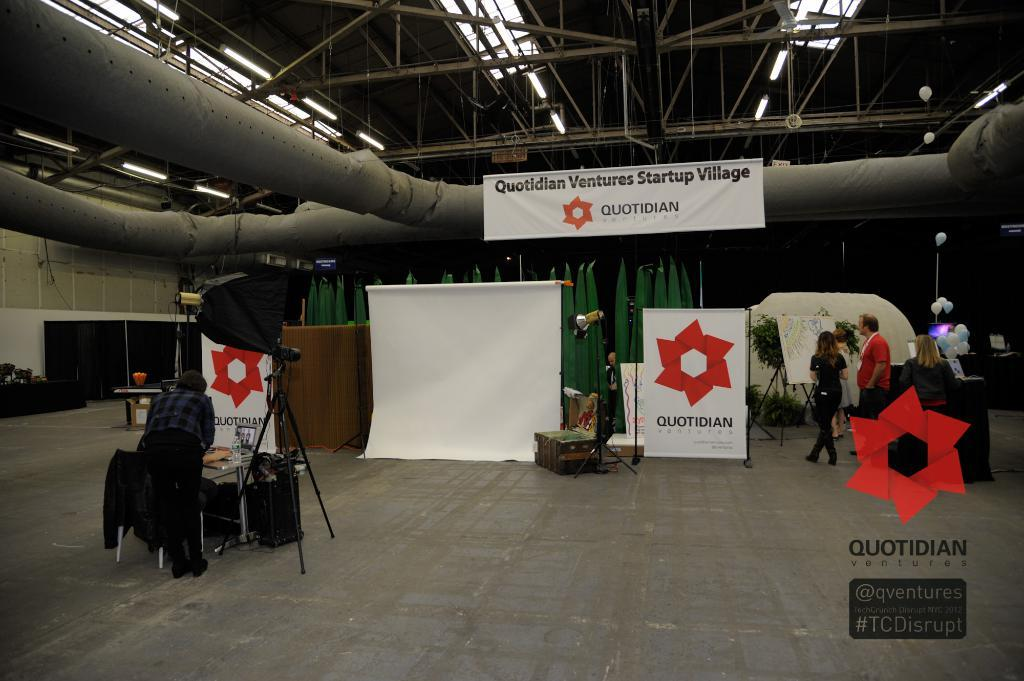<image>
Describe the image concisely. a bulidling with a poster sign inside of it that says quotidian 